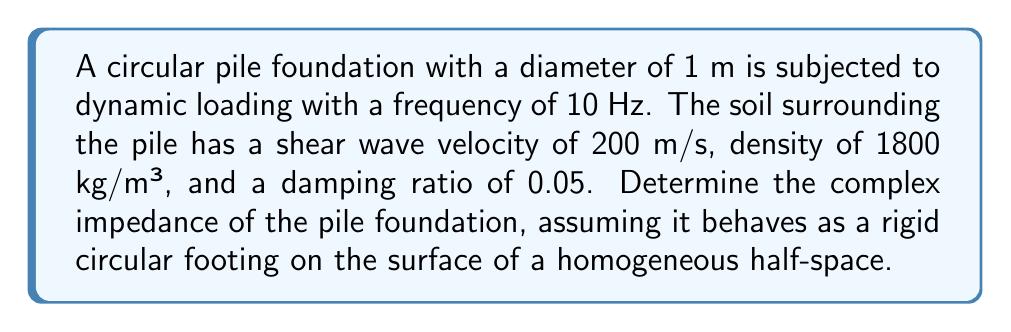What is the answer to this math problem? To determine the complex impedance of the pile foundation, we'll follow these steps:

1. Calculate the shear modulus of the soil:
   $G = \rho V_s^2$
   where $\rho$ is the soil density and $V_s$ is the shear wave velocity.
   $G = 1800 \cdot 200^2 = 72 \times 10^6$ Pa

2. Calculate the dimensionless frequency $a_0$:
   $a_0 = \frac{\omega r}{V_s} = \frac{2\pi f r}{V_s}$
   where $f$ is the loading frequency and $r$ is the pile radius.
   $a_0 = \frac{2\pi \cdot 10 \cdot 0.5}{200} = 1.57$

3. Determine the dynamic stiffness coefficients $k$ and $c$ from charts or equations. For this problem, we'll use simplified equations:
   $k = \frac{8Gr}{2-\nu}(1 + 0.5a_0)$
   $c = \frac{4.6Gr}{V_s}(1 + 0.025a_0)$
   where $\nu$ is Poisson's ratio (assumed to be 0.3 for this soil).

4. Calculate $k$ and $c$:
   $k = \frac{8 \cdot 72 \times 10^6 \cdot 0.5}{2-0.3}(1 + 0.5 \cdot 1.57) = 3.44 \times 10^8$ N/m
   $c = \frac{4.6 \cdot 72 \times 10^6 \cdot 0.5}{200}(1 + 0.025 \cdot 1.57) = 8.42 \times 10^5$ Ns/m

5. The complex impedance is given by:
   $Z = k + i\omega c$
   where $\omega = 2\pi f$

6. Calculate the complex impedance:
   $Z = 3.44 \times 10^8 + i(2\pi \cdot 10 \cdot 8.42 \times 10^5)$
   $Z = 3.44 \times 10^8 + i5.29 \times 10^7$ N/m
Answer: $Z = 3.44 \times 10^8 + i5.29 \times 10^7$ N/m 